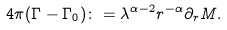Convert formula to latex. <formula><loc_0><loc_0><loc_500><loc_500>4 \pi ( \Gamma - \Gamma _ { 0 } ) \colon = \lambda ^ { \alpha - 2 } r ^ { - \alpha } \partial _ { r } M .</formula> 